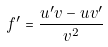<formula> <loc_0><loc_0><loc_500><loc_500>f ^ { \prime } = \frac { u ^ { \prime } v - u v ^ { \prime } } { v ^ { 2 } }</formula> 